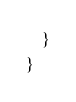Convert code to text. <code><loc_0><loc_0><loc_500><loc_500><_C#_>    }
}</code> 